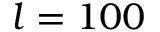Convert formula to latex. <formula><loc_0><loc_0><loc_500><loc_500>l = 1 0 0</formula> 